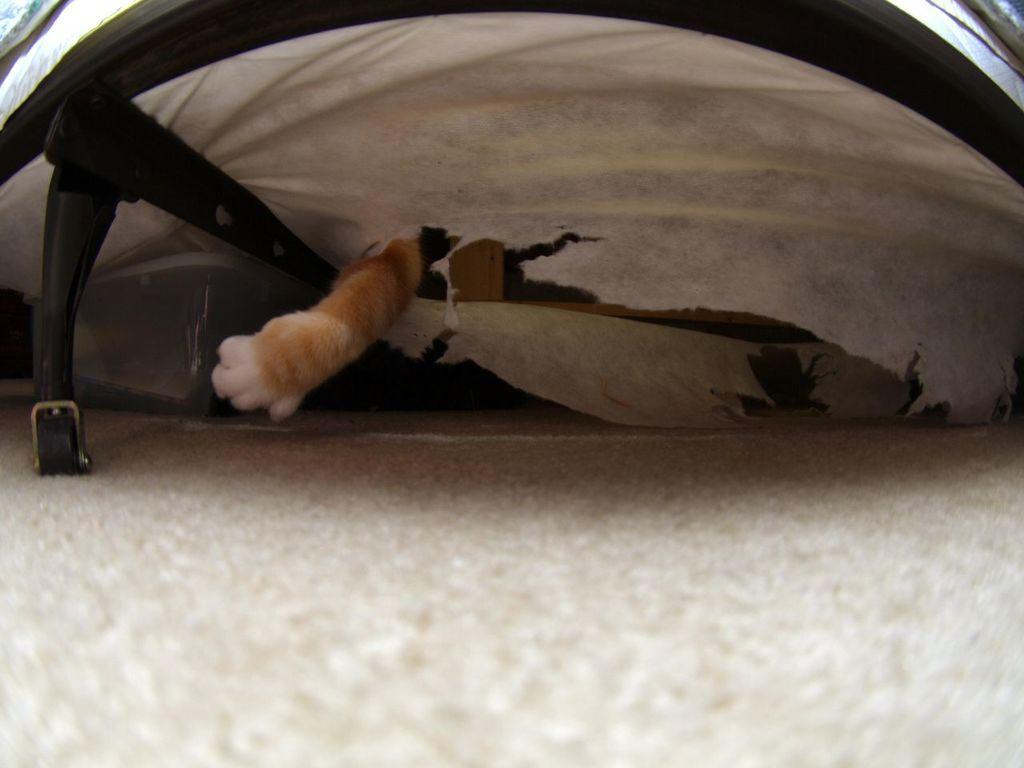Could you give a brief overview of what you see in this image? In this image I can see a cat leg, background I can see some object in white color. 